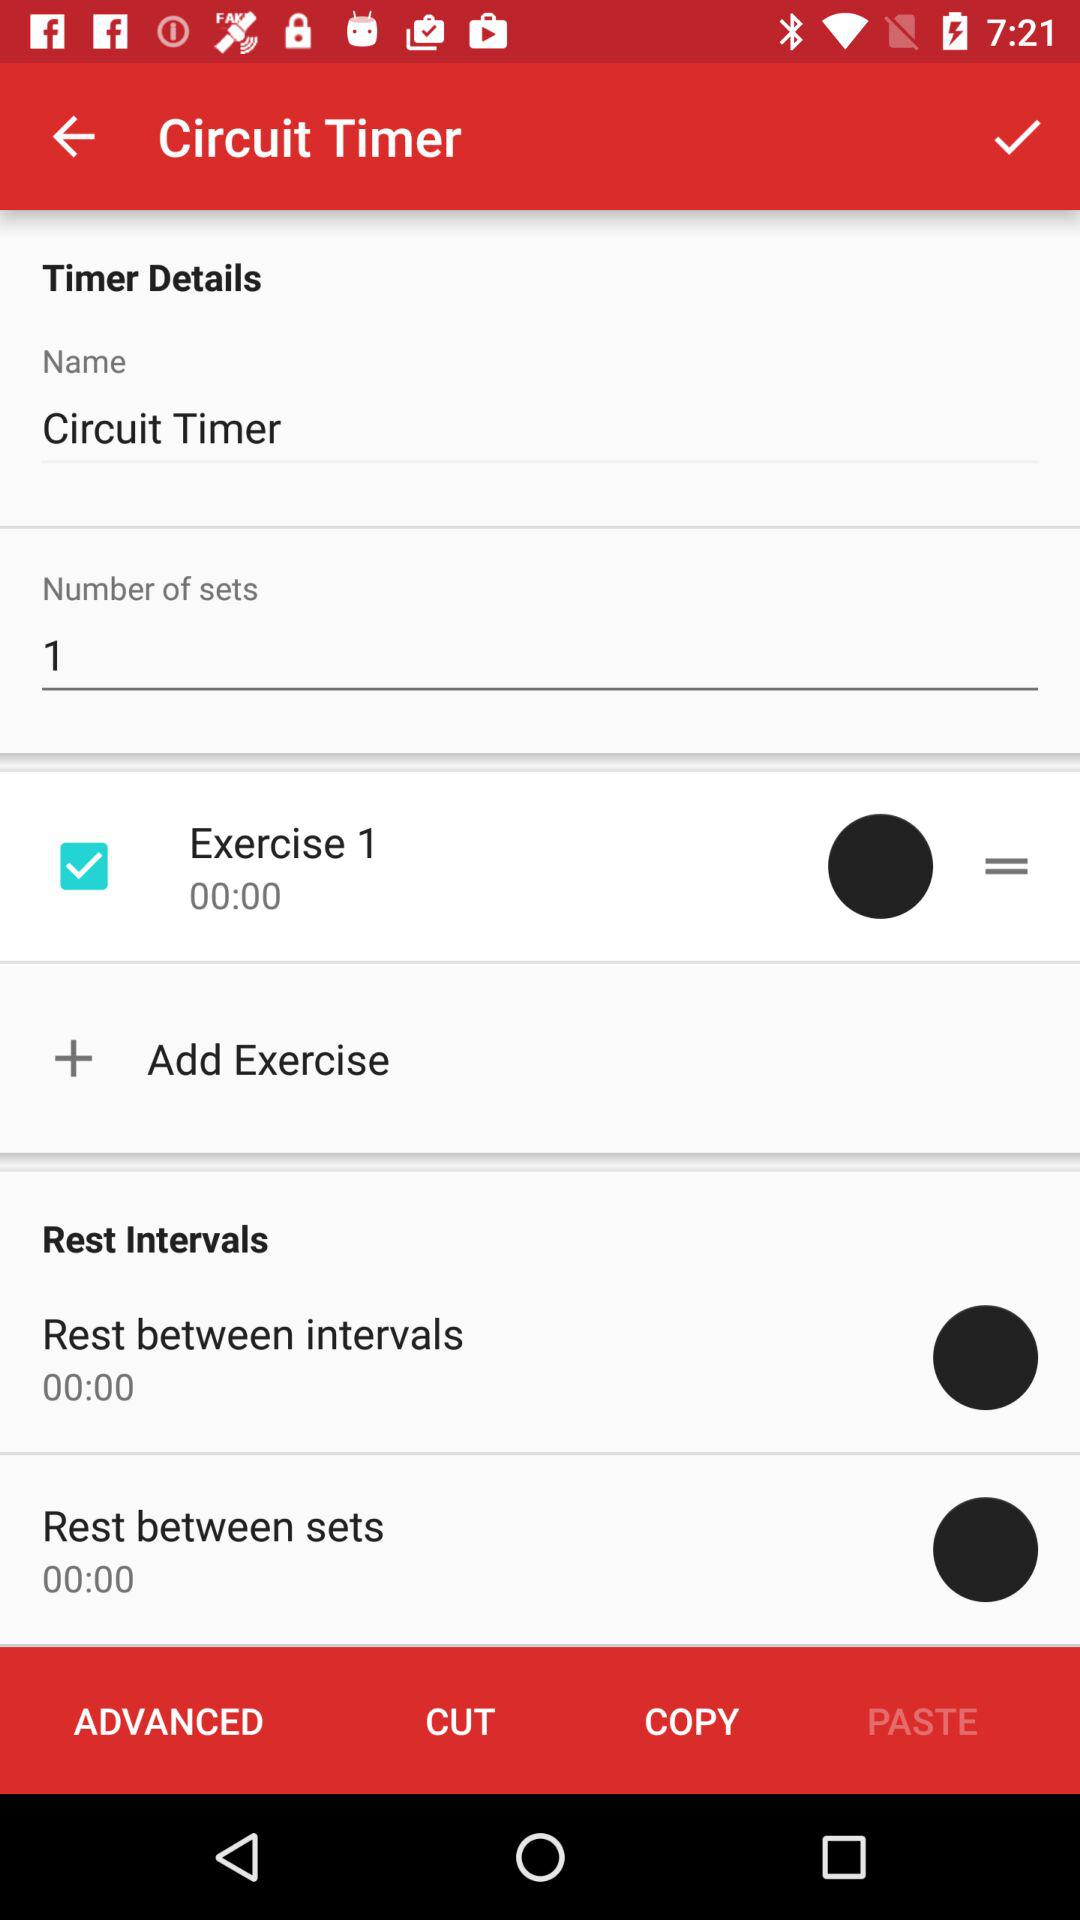How long is the rest between sets?
Answer the question using a single word or phrase. 00:00 